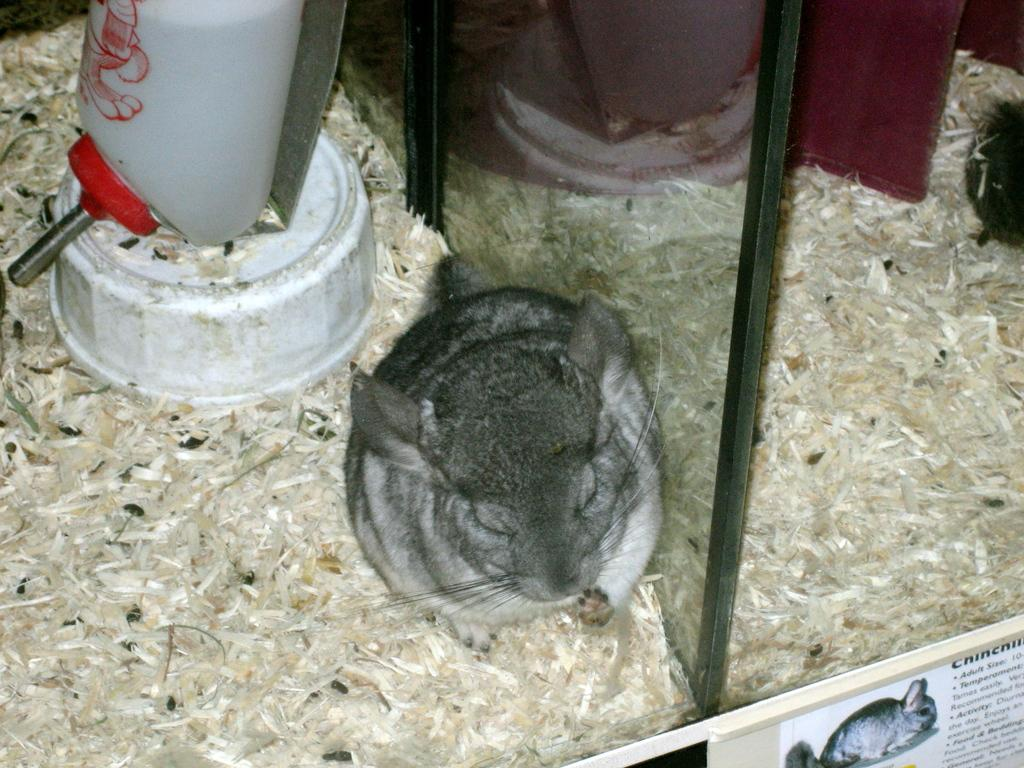What type of animal is in the image? There is a rabbit in the image. What object is also present in the image? There is a glass in the image. What can be used for displaying information or messages in the image? There is a text board in the image. What type of food or material is visible in the image? There are grains in the image. How does the rabbit sleep in the image? The image does not show the rabbit sleeping; it only shows the rabbit in its current state. What type of hearing aid is visible in the image? There is no hearing aid present in the image. 